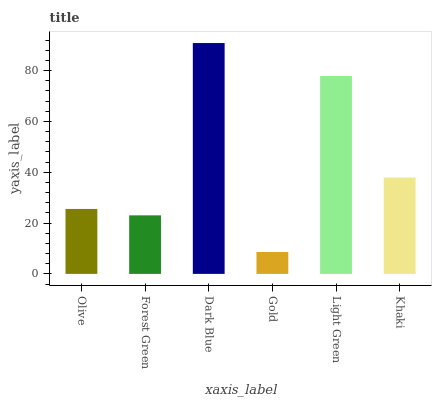Is Gold the minimum?
Answer yes or no. Yes. Is Dark Blue the maximum?
Answer yes or no. Yes. Is Forest Green the minimum?
Answer yes or no. No. Is Forest Green the maximum?
Answer yes or no. No. Is Olive greater than Forest Green?
Answer yes or no. Yes. Is Forest Green less than Olive?
Answer yes or no. Yes. Is Forest Green greater than Olive?
Answer yes or no. No. Is Olive less than Forest Green?
Answer yes or no. No. Is Khaki the high median?
Answer yes or no. Yes. Is Olive the low median?
Answer yes or no. Yes. Is Light Green the high median?
Answer yes or no. No. Is Khaki the low median?
Answer yes or no. No. 